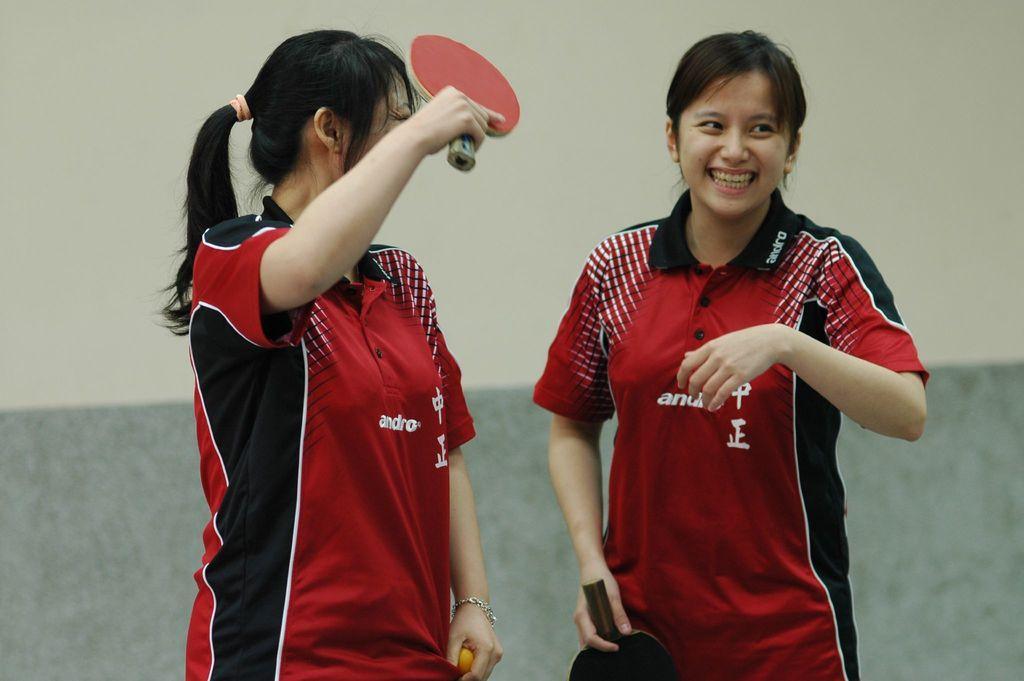In one or two sentences, can you explain what this image depicts? In this image i can see two women standing and smiling at the left side the woman is holding a bat at the back ground i can see wall. 